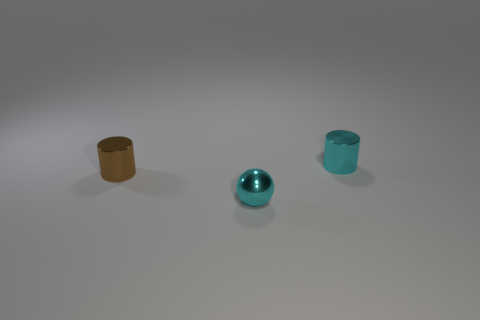What is the size of the other object that is the same shape as the brown thing?
Your answer should be very brief. Small. The small metal object that is in front of the tiny cyan cylinder and behind the cyan shiny sphere is what color?
Offer a very short reply. Brown. What number of cyan objects are cylinders or small objects?
Offer a very short reply. 2. Are there any yellow metallic balls?
Your response must be concise. No. There is a object that is on the right side of the small cyan thing that is on the left side of the tiny cyan cylinder; is there a tiny metal cylinder that is left of it?
Make the answer very short. Yes. Does the tiny brown thing have the same shape as the cyan thing behind the metal ball?
Your answer should be very brief. Yes. What color is the metal cylinder in front of the cyan metal cylinder that is behind the small object that is in front of the brown metal thing?
Your answer should be very brief. Brown. What number of things are shiny objects behind the tiny cyan sphere or small cylinders that are to the left of the tiny cyan cylinder?
Provide a succinct answer. 2. What number of other objects are the same color as the shiny sphere?
Offer a very short reply. 1. There is a tiny cyan thing to the right of the cyan shiny ball; is it the same shape as the tiny brown object?
Keep it short and to the point. Yes. 